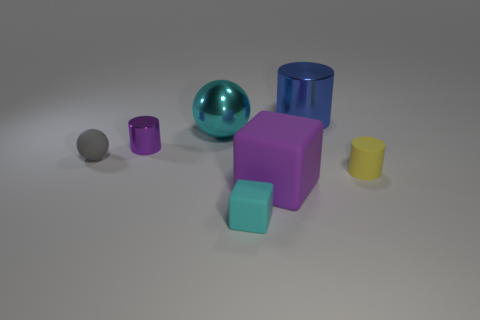What number of things are either tiny green metallic spheres or objects that are in front of the gray rubber sphere?
Offer a terse response. 3. Is there a cylinder that is in front of the cylinder left of the large cylinder?
Ensure brevity in your answer.  Yes. What shape is the metal thing that is to the right of the object in front of the large object that is in front of the gray rubber ball?
Provide a short and direct response. Cylinder. What is the color of the object that is left of the big purple rubber block and in front of the yellow cylinder?
Your response must be concise. Cyan. There is a metal thing in front of the shiny sphere; what shape is it?
Offer a terse response. Cylinder. What shape is the cyan thing that is the same material as the yellow thing?
Offer a terse response. Cube. How many matte objects are either gray things or tiny yellow spheres?
Provide a succinct answer. 1. What number of balls are in front of the small purple thing that is behind the large thing in front of the small yellow object?
Your answer should be very brief. 1. There is a sphere that is in front of the purple shiny cylinder; is it the same size as the cylinder that is in front of the matte sphere?
Offer a terse response. Yes. What is the material of the big blue object that is the same shape as the purple metal object?
Your answer should be very brief. Metal. 